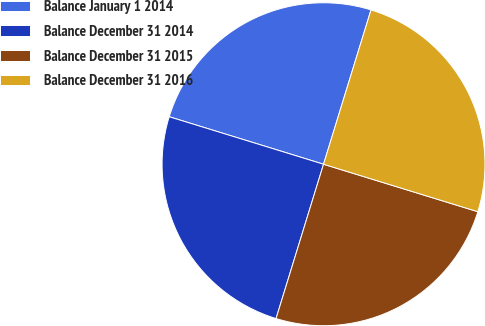Convert chart. <chart><loc_0><loc_0><loc_500><loc_500><pie_chart><fcel>Balance January 1 2014<fcel>Balance December 31 2014<fcel>Balance December 31 2015<fcel>Balance December 31 2016<nl><fcel>25.0%<fcel>25.0%<fcel>25.0%<fcel>25.0%<nl></chart> 